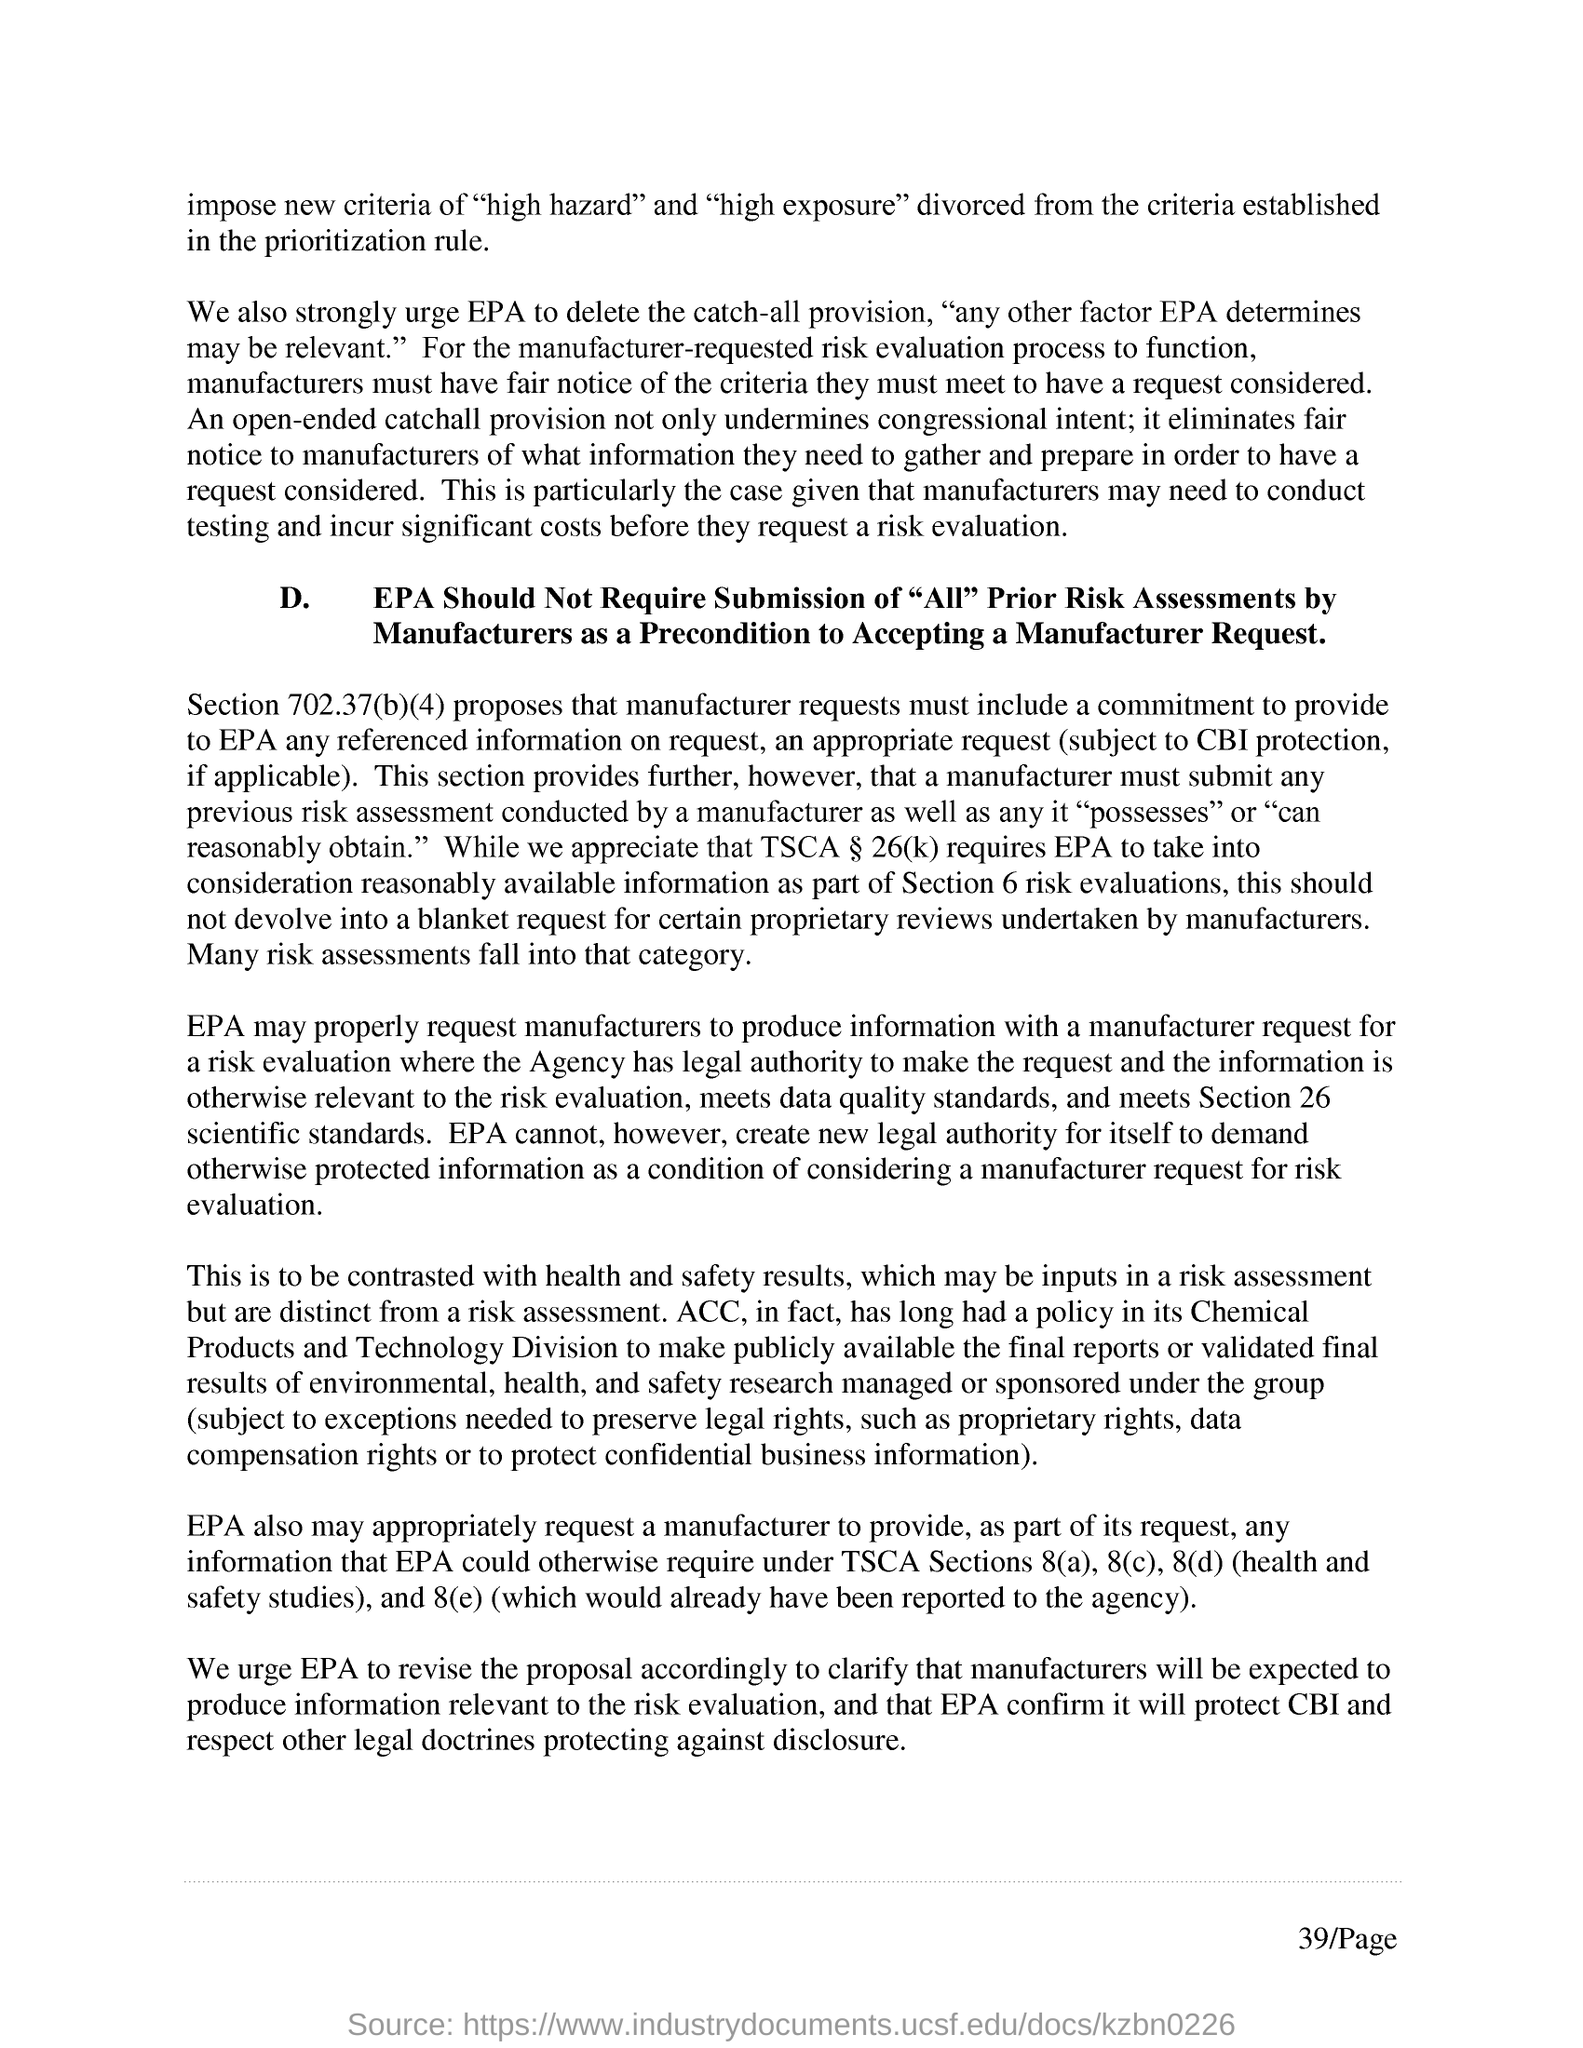What is the section mentioned in the first paragraph of d?
Your answer should be very brief. Section 702.37(b)(4). What is the page number?
Offer a terse response. 39. 